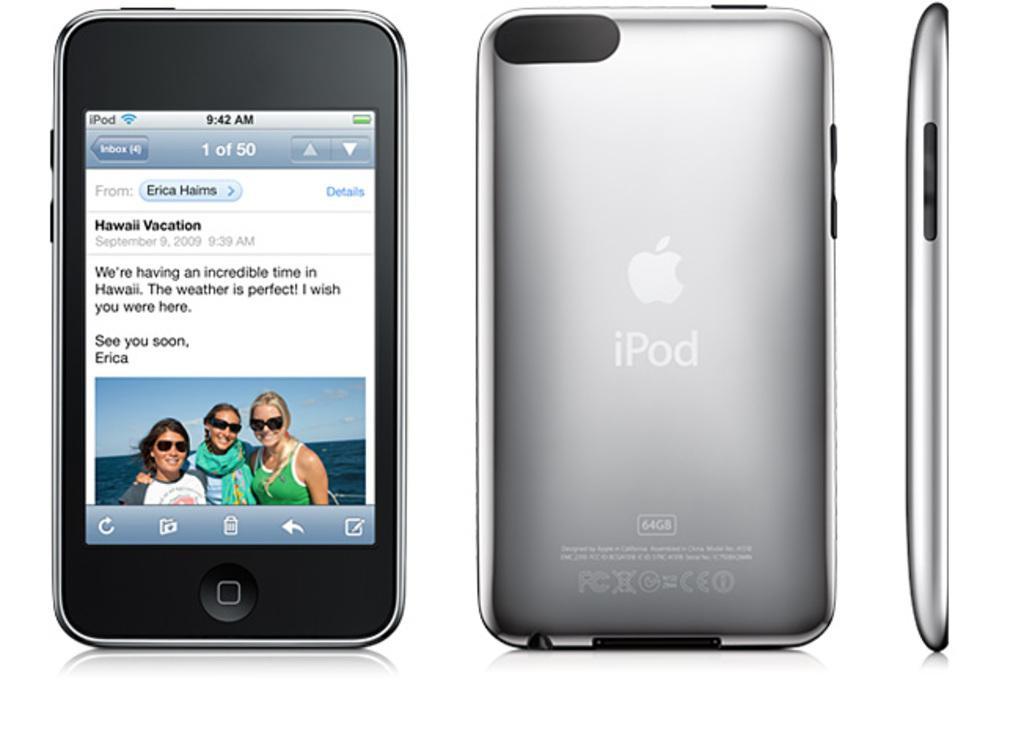Please provide a concise description of this image. In the image there is front,back and side view of an ipod. 